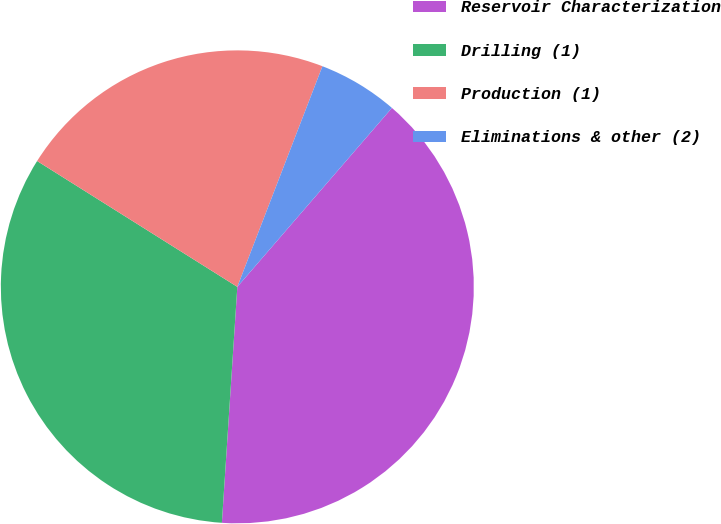Convert chart to OTSL. <chart><loc_0><loc_0><loc_500><loc_500><pie_chart><fcel>Reservoir Characterization<fcel>Drilling (1)<fcel>Production (1)<fcel>Eliminations & other (2)<nl><fcel>39.7%<fcel>32.89%<fcel>21.93%<fcel>5.48%<nl></chart> 